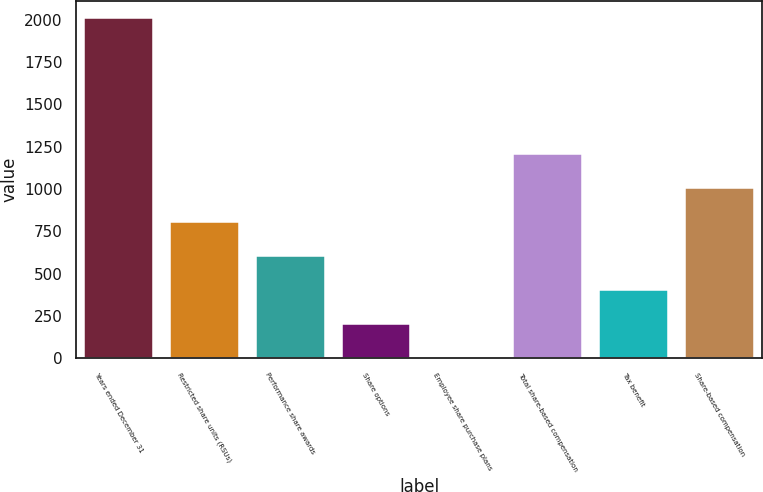Convert chart. <chart><loc_0><loc_0><loc_500><loc_500><bar_chart><fcel>Years ended December 31<fcel>Restricted share units (RSUs)<fcel>Performance share awards<fcel>Share options<fcel>Employee share purchase plans<fcel>Total share-based compensation<fcel>Tax benefit<fcel>Share-based compensation<nl><fcel>2011<fcel>808<fcel>607.5<fcel>206.5<fcel>6<fcel>1209<fcel>407<fcel>1008.5<nl></chart> 